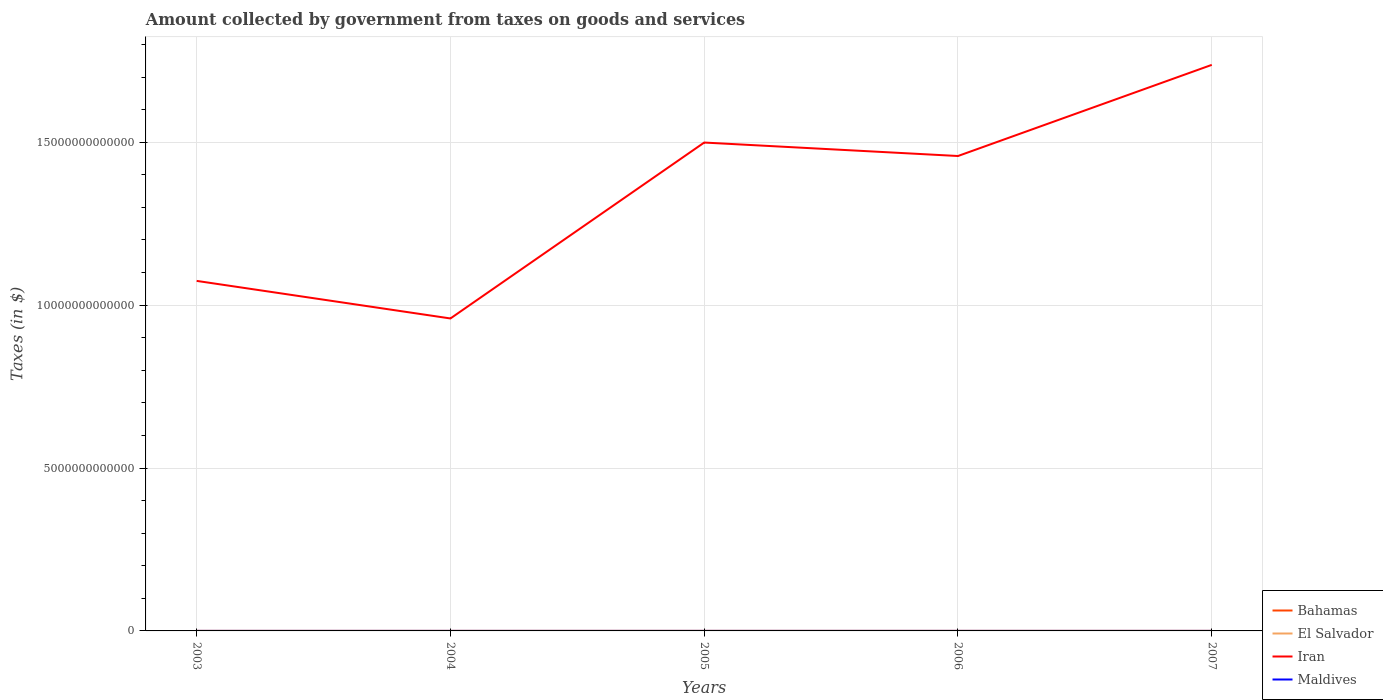How many different coloured lines are there?
Make the answer very short. 4. Is the number of lines equal to the number of legend labels?
Provide a short and direct response. Yes. Across all years, what is the maximum amount collected by government from taxes on goods and services in Bahamas?
Provide a short and direct response. 4.79e+07. What is the total amount collected by government from taxes on goods and services in Bahamas in the graph?
Your answer should be compact. -9.28e+07. What is the difference between the highest and the second highest amount collected by government from taxes on goods and services in Iran?
Make the answer very short. 7.78e+12. Is the amount collected by government from taxes on goods and services in Iran strictly greater than the amount collected by government from taxes on goods and services in Bahamas over the years?
Your answer should be very brief. No. What is the difference between two consecutive major ticks on the Y-axis?
Offer a terse response. 5.00e+12. How many legend labels are there?
Give a very brief answer. 4. How are the legend labels stacked?
Your response must be concise. Vertical. What is the title of the graph?
Your answer should be compact. Amount collected by government from taxes on goods and services. What is the label or title of the Y-axis?
Ensure brevity in your answer.  Taxes (in $). What is the Taxes (in $) in Bahamas in 2003?
Offer a terse response. 4.79e+07. What is the Taxes (in $) in El Salvador in 2003?
Offer a terse response. 9.86e+08. What is the Taxes (in $) of Iran in 2003?
Make the answer very short. 1.07e+13. What is the Taxes (in $) of Maldives in 2003?
Give a very brief answer. 3.95e+08. What is the Taxes (in $) in Bahamas in 2004?
Provide a succinct answer. 5.04e+07. What is the Taxes (in $) of El Salvador in 2004?
Ensure brevity in your answer.  1.02e+09. What is the Taxes (in $) of Iran in 2004?
Make the answer very short. 9.59e+12. What is the Taxes (in $) in Maldives in 2004?
Your answer should be compact. 4.50e+08. What is the Taxes (in $) in Bahamas in 2005?
Give a very brief answer. 6.96e+07. What is the Taxes (in $) in El Salvador in 2005?
Make the answer very short. 1.21e+09. What is the Taxes (in $) of Iran in 2005?
Your answer should be compact. 1.50e+13. What is the Taxes (in $) of Maldives in 2005?
Offer a very short reply. 3.91e+08. What is the Taxes (in $) in Bahamas in 2006?
Offer a terse response. 1.58e+08. What is the Taxes (in $) in El Salvador in 2006?
Your response must be concise. 1.47e+09. What is the Taxes (in $) of Iran in 2006?
Your answer should be very brief. 1.46e+13. What is the Taxes (in $) of Maldives in 2006?
Give a very brief answer. 5.49e+08. What is the Taxes (in $) in Bahamas in 2007?
Make the answer very short. 1.62e+08. What is the Taxes (in $) of El Salvador in 2007?
Provide a short and direct response. 1.66e+09. What is the Taxes (in $) of Iran in 2007?
Your answer should be compact. 1.74e+13. What is the Taxes (in $) of Maldives in 2007?
Your answer should be compact. 6.08e+08. Across all years, what is the maximum Taxes (in $) in Bahamas?
Give a very brief answer. 1.62e+08. Across all years, what is the maximum Taxes (in $) of El Salvador?
Your answer should be compact. 1.66e+09. Across all years, what is the maximum Taxes (in $) of Iran?
Provide a succinct answer. 1.74e+13. Across all years, what is the maximum Taxes (in $) in Maldives?
Make the answer very short. 6.08e+08. Across all years, what is the minimum Taxes (in $) of Bahamas?
Your answer should be compact. 4.79e+07. Across all years, what is the minimum Taxes (in $) in El Salvador?
Give a very brief answer. 9.86e+08. Across all years, what is the minimum Taxes (in $) of Iran?
Provide a succinct answer. 9.59e+12. Across all years, what is the minimum Taxes (in $) in Maldives?
Ensure brevity in your answer.  3.91e+08. What is the total Taxes (in $) of Bahamas in the graph?
Provide a succinct answer. 4.89e+08. What is the total Taxes (in $) in El Salvador in the graph?
Provide a short and direct response. 6.34e+09. What is the total Taxes (in $) of Iran in the graph?
Provide a short and direct response. 6.73e+13. What is the total Taxes (in $) of Maldives in the graph?
Provide a succinct answer. 2.39e+09. What is the difference between the Taxes (in $) of Bahamas in 2003 and that in 2004?
Your answer should be very brief. -2.48e+06. What is the difference between the Taxes (in $) in El Salvador in 2003 and that in 2004?
Provide a short and direct response. -3.62e+07. What is the difference between the Taxes (in $) in Iran in 2003 and that in 2004?
Provide a short and direct response. 1.15e+12. What is the difference between the Taxes (in $) of Maldives in 2003 and that in 2004?
Offer a terse response. -5.57e+07. What is the difference between the Taxes (in $) of Bahamas in 2003 and that in 2005?
Keep it short and to the point. -2.17e+07. What is the difference between the Taxes (in $) in El Salvador in 2003 and that in 2005?
Your answer should be very brief. -2.20e+08. What is the difference between the Taxes (in $) in Iran in 2003 and that in 2005?
Offer a very short reply. -4.25e+12. What is the difference between the Taxes (in $) in Maldives in 2003 and that in 2005?
Your response must be concise. 3.60e+06. What is the difference between the Taxes (in $) in Bahamas in 2003 and that in 2006?
Give a very brief answer. -1.10e+08. What is the difference between the Taxes (in $) in El Salvador in 2003 and that in 2006?
Offer a very short reply. -4.86e+08. What is the difference between the Taxes (in $) of Iran in 2003 and that in 2006?
Offer a very short reply. -3.83e+12. What is the difference between the Taxes (in $) in Maldives in 2003 and that in 2006?
Keep it short and to the point. -1.55e+08. What is the difference between the Taxes (in $) in Bahamas in 2003 and that in 2007?
Your answer should be compact. -1.15e+08. What is the difference between the Taxes (in $) of El Salvador in 2003 and that in 2007?
Ensure brevity in your answer.  -6.72e+08. What is the difference between the Taxes (in $) of Iran in 2003 and that in 2007?
Offer a terse response. -6.63e+12. What is the difference between the Taxes (in $) of Maldives in 2003 and that in 2007?
Your answer should be very brief. -2.13e+08. What is the difference between the Taxes (in $) in Bahamas in 2004 and that in 2005?
Your response must be concise. -1.92e+07. What is the difference between the Taxes (in $) of El Salvador in 2004 and that in 2005?
Keep it short and to the point. -1.83e+08. What is the difference between the Taxes (in $) of Iran in 2004 and that in 2005?
Give a very brief answer. -5.40e+12. What is the difference between the Taxes (in $) in Maldives in 2004 and that in 2005?
Give a very brief answer. 5.93e+07. What is the difference between the Taxes (in $) in Bahamas in 2004 and that in 2006?
Provide a succinct answer. -1.08e+08. What is the difference between the Taxes (in $) in El Salvador in 2004 and that in 2006?
Offer a very short reply. -4.50e+08. What is the difference between the Taxes (in $) in Iran in 2004 and that in 2006?
Keep it short and to the point. -4.99e+12. What is the difference between the Taxes (in $) of Maldives in 2004 and that in 2006?
Your answer should be very brief. -9.89e+07. What is the difference between the Taxes (in $) of Bahamas in 2004 and that in 2007?
Provide a short and direct response. -1.12e+08. What is the difference between the Taxes (in $) of El Salvador in 2004 and that in 2007?
Provide a succinct answer. -6.36e+08. What is the difference between the Taxes (in $) of Iran in 2004 and that in 2007?
Provide a short and direct response. -7.78e+12. What is the difference between the Taxes (in $) of Maldives in 2004 and that in 2007?
Your answer should be very brief. -1.57e+08. What is the difference between the Taxes (in $) in Bahamas in 2005 and that in 2006?
Your response must be concise. -8.88e+07. What is the difference between the Taxes (in $) in El Salvador in 2005 and that in 2006?
Provide a succinct answer. -2.67e+08. What is the difference between the Taxes (in $) of Iran in 2005 and that in 2006?
Give a very brief answer. 4.13e+11. What is the difference between the Taxes (in $) in Maldives in 2005 and that in 2006?
Your response must be concise. -1.58e+08. What is the difference between the Taxes (in $) of Bahamas in 2005 and that in 2007?
Offer a very short reply. -9.28e+07. What is the difference between the Taxes (in $) in El Salvador in 2005 and that in 2007?
Give a very brief answer. -4.52e+08. What is the difference between the Taxes (in $) of Iran in 2005 and that in 2007?
Provide a succinct answer. -2.38e+12. What is the difference between the Taxes (in $) in Maldives in 2005 and that in 2007?
Offer a very short reply. -2.17e+08. What is the difference between the Taxes (in $) in Bahamas in 2006 and that in 2007?
Make the answer very short. -4.03e+06. What is the difference between the Taxes (in $) in El Salvador in 2006 and that in 2007?
Give a very brief answer. -1.86e+08. What is the difference between the Taxes (in $) of Iran in 2006 and that in 2007?
Give a very brief answer. -2.80e+12. What is the difference between the Taxes (in $) in Maldives in 2006 and that in 2007?
Provide a short and direct response. -5.84e+07. What is the difference between the Taxes (in $) in Bahamas in 2003 and the Taxes (in $) in El Salvador in 2004?
Ensure brevity in your answer.  -9.74e+08. What is the difference between the Taxes (in $) in Bahamas in 2003 and the Taxes (in $) in Iran in 2004?
Your answer should be very brief. -9.59e+12. What is the difference between the Taxes (in $) of Bahamas in 2003 and the Taxes (in $) of Maldives in 2004?
Give a very brief answer. -4.03e+08. What is the difference between the Taxes (in $) in El Salvador in 2003 and the Taxes (in $) in Iran in 2004?
Provide a succinct answer. -9.59e+12. What is the difference between the Taxes (in $) in El Salvador in 2003 and the Taxes (in $) in Maldives in 2004?
Make the answer very short. 5.36e+08. What is the difference between the Taxes (in $) of Iran in 2003 and the Taxes (in $) of Maldives in 2004?
Your answer should be very brief. 1.07e+13. What is the difference between the Taxes (in $) of Bahamas in 2003 and the Taxes (in $) of El Salvador in 2005?
Offer a very short reply. -1.16e+09. What is the difference between the Taxes (in $) in Bahamas in 2003 and the Taxes (in $) in Iran in 2005?
Your response must be concise. -1.50e+13. What is the difference between the Taxes (in $) of Bahamas in 2003 and the Taxes (in $) of Maldives in 2005?
Offer a terse response. -3.43e+08. What is the difference between the Taxes (in $) in El Salvador in 2003 and the Taxes (in $) in Iran in 2005?
Keep it short and to the point. -1.50e+13. What is the difference between the Taxes (in $) of El Salvador in 2003 and the Taxes (in $) of Maldives in 2005?
Give a very brief answer. 5.95e+08. What is the difference between the Taxes (in $) of Iran in 2003 and the Taxes (in $) of Maldives in 2005?
Ensure brevity in your answer.  1.07e+13. What is the difference between the Taxes (in $) of Bahamas in 2003 and the Taxes (in $) of El Salvador in 2006?
Your answer should be compact. -1.42e+09. What is the difference between the Taxes (in $) in Bahamas in 2003 and the Taxes (in $) in Iran in 2006?
Offer a very short reply. -1.46e+13. What is the difference between the Taxes (in $) in Bahamas in 2003 and the Taxes (in $) in Maldives in 2006?
Offer a very short reply. -5.02e+08. What is the difference between the Taxes (in $) in El Salvador in 2003 and the Taxes (in $) in Iran in 2006?
Provide a short and direct response. -1.46e+13. What is the difference between the Taxes (in $) in El Salvador in 2003 and the Taxes (in $) in Maldives in 2006?
Give a very brief answer. 4.37e+08. What is the difference between the Taxes (in $) in Iran in 2003 and the Taxes (in $) in Maldives in 2006?
Your response must be concise. 1.07e+13. What is the difference between the Taxes (in $) of Bahamas in 2003 and the Taxes (in $) of El Salvador in 2007?
Your answer should be compact. -1.61e+09. What is the difference between the Taxes (in $) in Bahamas in 2003 and the Taxes (in $) in Iran in 2007?
Ensure brevity in your answer.  -1.74e+13. What is the difference between the Taxes (in $) in Bahamas in 2003 and the Taxes (in $) in Maldives in 2007?
Keep it short and to the point. -5.60e+08. What is the difference between the Taxes (in $) in El Salvador in 2003 and the Taxes (in $) in Iran in 2007?
Provide a succinct answer. -1.74e+13. What is the difference between the Taxes (in $) of El Salvador in 2003 and the Taxes (in $) of Maldives in 2007?
Make the answer very short. 3.78e+08. What is the difference between the Taxes (in $) in Iran in 2003 and the Taxes (in $) in Maldives in 2007?
Your response must be concise. 1.07e+13. What is the difference between the Taxes (in $) in Bahamas in 2004 and the Taxes (in $) in El Salvador in 2005?
Make the answer very short. -1.16e+09. What is the difference between the Taxes (in $) in Bahamas in 2004 and the Taxes (in $) in Iran in 2005?
Your answer should be compact. -1.50e+13. What is the difference between the Taxes (in $) in Bahamas in 2004 and the Taxes (in $) in Maldives in 2005?
Make the answer very short. -3.41e+08. What is the difference between the Taxes (in $) of El Salvador in 2004 and the Taxes (in $) of Iran in 2005?
Provide a short and direct response. -1.50e+13. What is the difference between the Taxes (in $) in El Salvador in 2004 and the Taxes (in $) in Maldives in 2005?
Keep it short and to the point. 6.31e+08. What is the difference between the Taxes (in $) in Iran in 2004 and the Taxes (in $) in Maldives in 2005?
Offer a terse response. 9.59e+12. What is the difference between the Taxes (in $) in Bahamas in 2004 and the Taxes (in $) in El Salvador in 2006?
Ensure brevity in your answer.  -1.42e+09. What is the difference between the Taxes (in $) in Bahamas in 2004 and the Taxes (in $) in Iran in 2006?
Provide a succinct answer. -1.46e+13. What is the difference between the Taxes (in $) in Bahamas in 2004 and the Taxes (in $) in Maldives in 2006?
Offer a very short reply. -4.99e+08. What is the difference between the Taxes (in $) of El Salvador in 2004 and the Taxes (in $) of Iran in 2006?
Provide a short and direct response. -1.46e+13. What is the difference between the Taxes (in $) in El Salvador in 2004 and the Taxes (in $) in Maldives in 2006?
Offer a terse response. 4.73e+08. What is the difference between the Taxes (in $) in Iran in 2004 and the Taxes (in $) in Maldives in 2006?
Ensure brevity in your answer.  9.59e+12. What is the difference between the Taxes (in $) of Bahamas in 2004 and the Taxes (in $) of El Salvador in 2007?
Provide a succinct answer. -1.61e+09. What is the difference between the Taxes (in $) in Bahamas in 2004 and the Taxes (in $) in Iran in 2007?
Ensure brevity in your answer.  -1.74e+13. What is the difference between the Taxes (in $) of Bahamas in 2004 and the Taxes (in $) of Maldives in 2007?
Provide a short and direct response. -5.57e+08. What is the difference between the Taxes (in $) in El Salvador in 2004 and the Taxes (in $) in Iran in 2007?
Give a very brief answer. -1.74e+13. What is the difference between the Taxes (in $) in El Salvador in 2004 and the Taxes (in $) in Maldives in 2007?
Your response must be concise. 4.14e+08. What is the difference between the Taxes (in $) of Iran in 2004 and the Taxes (in $) of Maldives in 2007?
Keep it short and to the point. 9.59e+12. What is the difference between the Taxes (in $) in Bahamas in 2005 and the Taxes (in $) in El Salvador in 2006?
Keep it short and to the point. -1.40e+09. What is the difference between the Taxes (in $) of Bahamas in 2005 and the Taxes (in $) of Iran in 2006?
Keep it short and to the point. -1.46e+13. What is the difference between the Taxes (in $) in Bahamas in 2005 and the Taxes (in $) in Maldives in 2006?
Make the answer very short. -4.80e+08. What is the difference between the Taxes (in $) of El Salvador in 2005 and the Taxes (in $) of Iran in 2006?
Keep it short and to the point. -1.46e+13. What is the difference between the Taxes (in $) in El Salvador in 2005 and the Taxes (in $) in Maldives in 2006?
Your response must be concise. 6.56e+08. What is the difference between the Taxes (in $) of Iran in 2005 and the Taxes (in $) of Maldives in 2006?
Ensure brevity in your answer.  1.50e+13. What is the difference between the Taxes (in $) in Bahamas in 2005 and the Taxes (in $) in El Salvador in 2007?
Provide a short and direct response. -1.59e+09. What is the difference between the Taxes (in $) of Bahamas in 2005 and the Taxes (in $) of Iran in 2007?
Offer a very short reply. -1.74e+13. What is the difference between the Taxes (in $) in Bahamas in 2005 and the Taxes (in $) in Maldives in 2007?
Provide a succinct answer. -5.38e+08. What is the difference between the Taxes (in $) of El Salvador in 2005 and the Taxes (in $) of Iran in 2007?
Keep it short and to the point. -1.74e+13. What is the difference between the Taxes (in $) of El Salvador in 2005 and the Taxes (in $) of Maldives in 2007?
Your answer should be compact. 5.98e+08. What is the difference between the Taxes (in $) in Iran in 2005 and the Taxes (in $) in Maldives in 2007?
Your answer should be compact. 1.50e+13. What is the difference between the Taxes (in $) of Bahamas in 2006 and the Taxes (in $) of El Salvador in 2007?
Keep it short and to the point. -1.50e+09. What is the difference between the Taxes (in $) of Bahamas in 2006 and the Taxes (in $) of Iran in 2007?
Your answer should be compact. -1.74e+13. What is the difference between the Taxes (in $) of Bahamas in 2006 and the Taxes (in $) of Maldives in 2007?
Offer a terse response. -4.49e+08. What is the difference between the Taxes (in $) of El Salvador in 2006 and the Taxes (in $) of Iran in 2007?
Offer a terse response. -1.74e+13. What is the difference between the Taxes (in $) of El Salvador in 2006 and the Taxes (in $) of Maldives in 2007?
Offer a very short reply. 8.64e+08. What is the difference between the Taxes (in $) in Iran in 2006 and the Taxes (in $) in Maldives in 2007?
Your answer should be compact. 1.46e+13. What is the average Taxes (in $) of Bahamas per year?
Keep it short and to the point. 9.77e+07. What is the average Taxes (in $) in El Salvador per year?
Offer a terse response. 1.27e+09. What is the average Taxes (in $) in Iran per year?
Make the answer very short. 1.35e+13. What is the average Taxes (in $) of Maldives per year?
Ensure brevity in your answer.  4.79e+08. In the year 2003, what is the difference between the Taxes (in $) of Bahamas and Taxes (in $) of El Salvador?
Ensure brevity in your answer.  -9.38e+08. In the year 2003, what is the difference between the Taxes (in $) of Bahamas and Taxes (in $) of Iran?
Provide a succinct answer. -1.07e+13. In the year 2003, what is the difference between the Taxes (in $) in Bahamas and Taxes (in $) in Maldives?
Your response must be concise. -3.47e+08. In the year 2003, what is the difference between the Taxes (in $) of El Salvador and Taxes (in $) of Iran?
Offer a terse response. -1.07e+13. In the year 2003, what is the difference between the Taxes (in $) in El Salvador and Taxes (in $) in Maldives?
Keep it short and to the point. 5.91e+08. In the year 2003, what is the difference between the Taxes (in $) in Iran and Taxes (in $) in Maldives?
Your answer should be very brief. 1.07e+13. In the year 2004, what is the difference between the Taxes (in $) of Bahamas and Taxes (in $) of El Salvador?
Provide a short and direct response. -9.72e+08. In the year 2004, what is the difference between the Taxes (in $) in Bahamas and Taxes (in $) in Iran?
Provide a succinct answer. -9.59e+12. In the year 2004, what is the difference between the Taxes (in $) of Bahamas and Taxes (in $) of Maldives?
Ensure brevity in your answer.  -4.00e+08. In the year 2004, what is the difference between the Taxes (in $) of El Salvador and Taxes (in $) of Iran?
Provide a succinct answer. -9.59e+12. In the year 2004, what is the difference between the Taxes (in $) in El Salvador and Taxes (in $) in Maldives?
Provide a succinct answer. 5.72e+08. In the year 2004, what is the difference between the Taxes (in $) of Iran and Taxes (in $) of Maldives?
Your answer should be very brief. 9.59e+12. In the year 2005, what is the difference between the Taxes (in $) of Bahamas and Taxes (in $) of El Salvador?
Ensure brevity in your answer.  -1.14e+09. In the year 2005, what is the difference between the Taxes (in $) in Bahamas and Taxes (in $) in Iran?
Offer a very short reply. -1.50e+13. In the year 2005, what is the difference between the Taxes (in $) in Bahamas and Taxes (in $) in Maldives?
Give a very brief answer. -3.22e+08. In the year 2005, what is the difference between the Taxes (in $) in El Salvador and Taxes (in $) in Iran?
Your answer should be compact. -1.50e+13. In the year 2005, what is the difference between the Taxes (in $) in El Salvador and Taxes (in $) in Maldives?
Ensure brevity in your answer.  8.14e+08. In the year 2005, what is the difference between the Taxes (in $) of Iran and Taxes (in $) of Maldives?
Offer a very short reply. 1.50e+13. In the year 2006, what is the difference between the Taxes (in $) of Bahamas and Taxes (in $) of El Salvador?
Provide a succinct answer. -1.31e+09. In the year 2006, what is the difference between the Taxes (in $) of Bahamas and Taxes (in $) of Iran?
Offer a very short reply. -1.46e+13. In the year 2006, what is the difference between the Taxes (in $) in Bahamas and Taxes (in $) in Maldives?
Provide a short and direct response. -3.91e+08. In the year 2006, what is the difference between the Taxes (in $) of El Salvador and Taxes (in $) of Iran?
Offer a very short reply. -1.46e+13. In the year 2006, what is the difference between the Taxes (in $) of El Salvador and Taxes (in $) of Maldives?
Your answer should be very brief. 9.23e+08. In the year 2006, what is the difference between the Taxes (in $) in Iran and Taxes (in $) in Maldives?
Ensure brevity in your answer.  1.46e+13. In the year 2007, what is the difference between the Taxes (in $) in Bahamas and Taxes (in $) in El Salvador?
Give a very brief answer. -1.50e+09. In the year 2007, what is the difference between the Taxes (in $) in Bahamas and Taxes (in $) in Iran?
Keep it short and to the point. -1.74e+13. In the year 2007, what is the difference between the Taxes (in $) of Bahamas and Taxes (in $) of Maldives?
Give a very brief answer. -4.45e+08. In the year 2007, what is the difference between the Taxes (in $) in El Salvador and Taxes (in $) in Iran?
Your answer should be compact. -1.74e+13. In the year 2007, what is the difference between the Taxes (in $) in El Salvador and Taxes (in $) in Maldives?
Give a very brief answer. 1.05e+09. In the year 2007, what is the difference between the Taxes (in $) of Iran and Taxes (in $) of Maldives?
Make the answer very short. 1.74e+13. What is the ratio of the Taxes (in $) of Bahamas in 2003 to that in 2004?
Make the answer very short. 0.95. What is the ratio of the Taxes (in $) of El Salvador in 2003 to that in 2004?
Provide a succinct answer. 0.96. What is the ratio of the Taxes (in $) of Iran in 2003 to that in 2004?
Make the answer very short. 1.12. What is the ratio of the Taxes (in $) in Maldives in 2003 to that in 2004?
Your answer should be compact. 0.88. What is the ratio of the Taxes (in $) of Bahamas in 2003 to that in 2005?
Provide a short and direct response. 0.69. What is the ratio of the Taxes (in $) in El Salvador in 2003 to that in 2005?
Provide a succinct answer. 0.82. What is the ratio of the Taxes (in $) of Iran in 2003 to that in 2005?
Your answer should be compact. 0.72. What is the ratio of the Taxes (in $) of Maldives in 2003 to that in 2005?
Ensure brevity in your answer.  1.01. What is the ratio of the Taxes (in $) of Bahamas in 2003 to that in 2006?
Offer a very short reply. 0.3. What is the ratio of the Taxes (in $) in El Salvador in 2003 to that in 2006?
Your response must be concise. 0.67. What is the ratio of the Taxes (in $) of Iran in 2003 to that in 2006?
Give a very brief answer. 0.74. What is the ratio of the Taxes (in $) in Maldives in 2003 to that in 2006?
Keep it short and to the point. 0.72. What is the ratio of the Taxes (in $) of Bahamas in 2003 to that in 2007?
Provide a short and direct response. 0.29. What is the ratio of the Taxes (in $) of El Salvador in 2003 to that in 2007?
Provide a short and direct response. 0.59. What is the ratio of the Taxes (in $) of Iran in 2003 to that in 2007?
Provide a short and direct response. 0.62. What is the ratio of the Taxes (in $) of Maldives in 2003 to that in 2007?
Provide a short and direct response. 0.65. What is the ratio of the Taxes (in $) of Bahamas in 2004 to that in 2005?
Your response must be concise. 0.72. What is the ratio of the Taxes (in $) in El Salvador in 2004 to that in 2005?
Your answer should be compact. 0.85. What is the ratio of the Taxes (in $) in Iran in 2004 to that in 2005?
Keep it short and to the point. 0.64. What is the ratio of the Taxes (in $) of Maldives in 2004 to that in 2005?
Your answer should be very brief. 1.15. What is the ratio of the Taxes (in $) of Bahamas in 2004 to that in 2006?
Provide a succinct answer. 0.32. What is the ratio of the Taxes (in $) of El Salvador in 2004 to that in 2006?
Provide a short and direct response. 0.69. What is the ratio of the Taxes (in $) in Iran in 2004 to that in 2006?
Your answer should be very brief. 0.66. What is the ratio of the Taxes (in $) in Maldives in 2004 to that in 2006?
Provide a succinct answer. 0.82. What is the ratio of the Taxes (in $) of Bahamas in 2004 to that in 2007?
Ensure brevity in your answer.  0.31. What is the ratio of the Taxes (in $) in El Salvador in 2004 to that in 2007?
Your answer should be very brief. 0.62. What is the ratio of the Taxes (in $) in Iran in 2004 to that in 2007?
Your answer should be compact. 0.55. What is the ratio of the Taxes (in $) of Maldives in 2004 to that in 2007?
Give a very brief answer. 0.74. What is the ratio of the Taxes (in $) of Bahamas in 2005 to that in 2006?
Provide a succinct answer. 0.44. What is the ratio of the Taxes (in $) of El Salvador in 2005 to that in 2006?
Your response must be concise. 0.82. What is the ratio of the Taxes (in $) in Iran in 2005 to that in 2006?
Provide a short and direct response. 1.03. What is the ratio of the Taxes (in $) of Maldives in 2005 to that in 2006?
Your answer should be very brief. 0.71. What is the ratio of the Taxes (in $) of Bahamas in 2005 to that in 2007?
Keep it short and to the point. 0.43. What is the ratio of the Taxes (in $) of El Salvador in 2005 to that in 2007?
Keep it short and to the point. 0.73. What is the ratio of the Taxes (in $) in Iran in 2005 to that in 2007?
Provide a succinct answer. 0.86. What is the ratio of the Taxes (in $) of Maldives in 2005 to that in 2007?
Keep it short and to the point. 0.64. What is the ratio of the Taxes (in $) in Bahamas in 2006 to that in 2007?
Your answer should be very brief. 0.98. What is the ratio of the Taxes (in $) of El Salvador in 2006 to that in 2007?
Give a very brief answer. 0.89. What is the ratio of the Taxes (in $) of Iran in 2006 to that in 2007?
Provide a short and direct response. 0.84. What is the ratio of the Taxes (in $) in Maldives in 2006 to that in 2007?
Make the answer very short. 0.9. What is the difference between the highest and the second highest Taxes (in $) of Bahamas?
Your response must be concise. 4.03e+06. What is the difference between the highest and the second highest Taxes (in $) of El Salvador?
Offer a very short reply. 1.86e+08. What is the difference between the highest and the second highest Taxes (in $) of Iran?
Provide a succinct answer. 2.38e+12. What is the difference between the highest and the second highest Taxes (in $) in Maldives?
Ensure brevity in your answer.  5.84e+07. What is the difference between the highest and the lowest Taxes (in $) in Bahamas?
Offer a terse response. 1.15e+08. What is the difference between the highest and the lowest Taxes (in $) in El Salvador?
Your response must be concise. 6.72e+08. What is the difference between the highest and the lowest Taxes (in $) in Iran?
Ensure brevity in your answer.  7.78e+12. What is the difference between the highest and the lowest Taxes (in $) of Maldives?
Ensure brevity in your answer.  2.17e+08. 